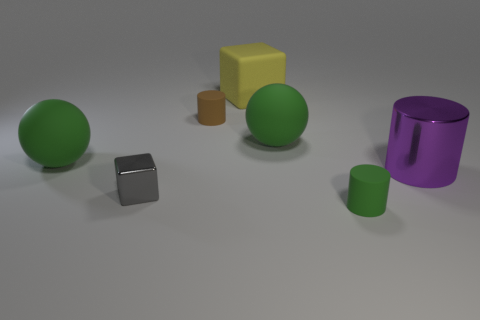Are there any objects that have a similar shape but different sizes? Yes, there are two cylindrical objects that share a similar shape but vary in size. The larger one is purple with a metallic finish, while the smaller one is green with a matte texture. 